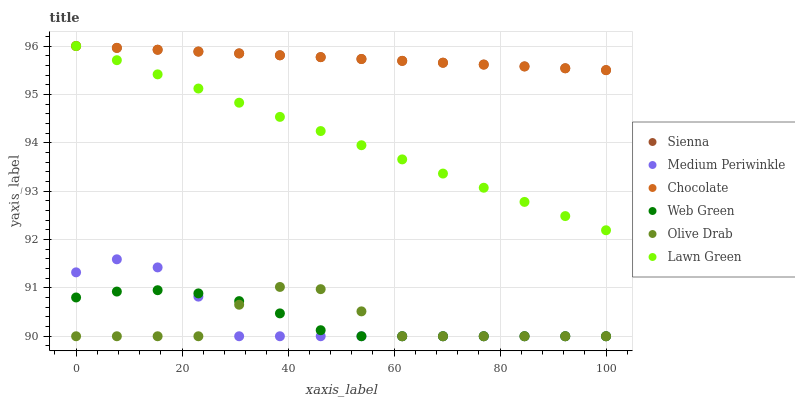Does Olive Drab have the minimum area under the curve?
Answer yes or no. Yes. Does Sienna have the maximum area under the curve?
Answer yes or no. Yes. Does Medium Periwinkle have the minimum area under the curve?
Answer yes or no. No. Does Medium Periwinkle have the maximum area under the curve?
Answer yes or no. No. Is Sienna the smoothest?
Answer yes or no. Yes. Is Olive Drab the roughest?
Answer yes or no. Yes. Is Medium Periwinkle the smoothest?
Answer yes or no. No. Is Medium Periwinkle the roughest?
Answer yes or no. No. Does Medium Periwinkle have the lowest value?
Answer yes or no. Yes. Does Chocolate have the lowest value?
Answer yes or no. No. Does Sienna have the highest value?
Answer yes or no. Yes. Does Medium Periwinkle have the highest value?
Answer yes or no. No. Is Web Green less than Chocolate?
Answer yes or no. Yes. Is Chocolate greater than Medium Periwinkle?
Answer yes or no. Yes. Does Web Green intersect Olive Drab?
Answer yes or no. Yes. Is Web Green less than Olive Drab?
Answer yes or no. No. Is Web Green greater than Olive Drab?
Answer yes or no. No. Does Web Green intersect Chocolate?
Answer yes or no. No. 